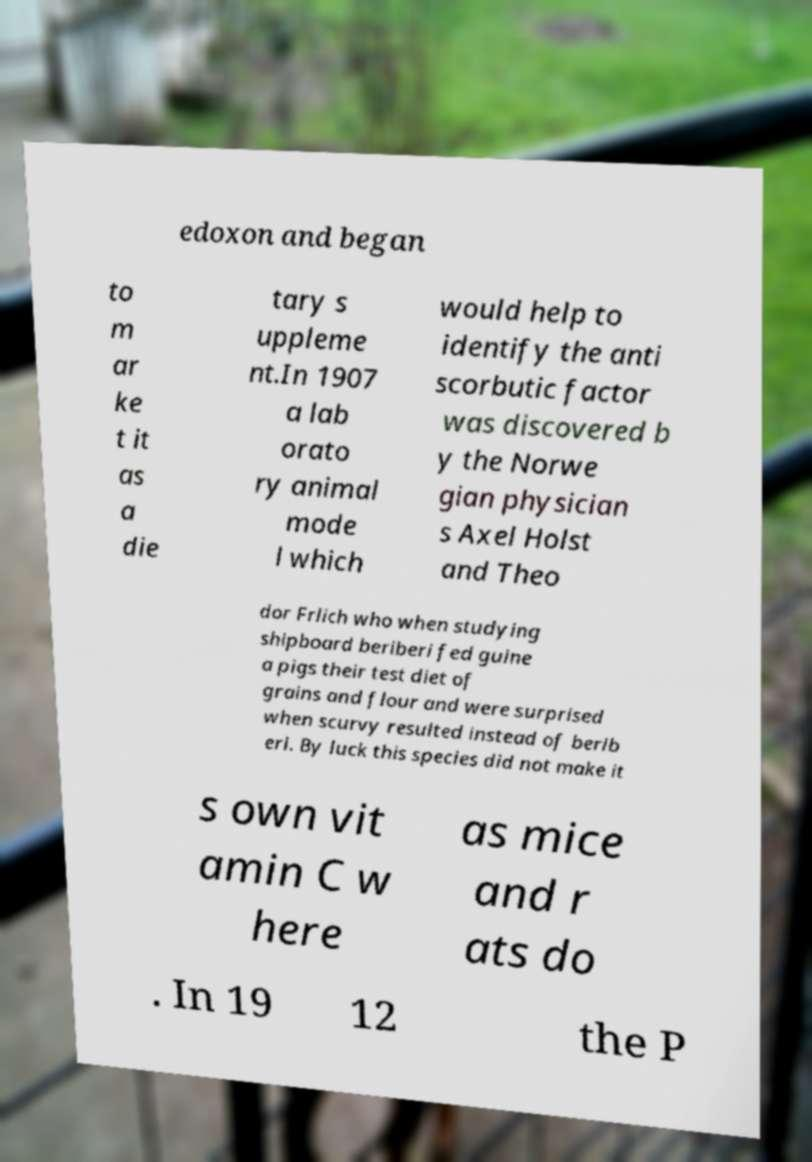I need the written content from this picture converted into text. Can you do that? edoxon and began to m ar ke t it as a die tary s uppleme nt.In 1907 a lab orato ry animal mode l which would help to identify the anti scorbutic factor was discovered b y the Norwe gian physician s Axel Holst and Theo dor Frlich who when studying shipboard beriberi fed guine a pigs their test diet of grains and flour and were surprised when scurvy resulted instead of berib eri. By luck this species did not make it s own vit amin C w here as mice and r ats do . In 19 12 the P 